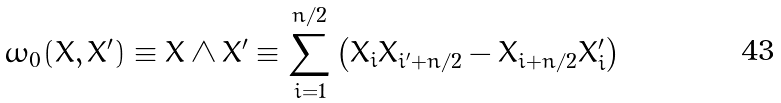<formula> <loc_0><loc_0><loc_500><loc_500>\omega _ { 0 } ( X , X ^ { \prime } ) \equiv X \wedge X ^ { \prime } \equiv \sum _ { i = 1 } ^ { n / 2 } \left ( X _ { i } X _ { i ^ { \prime } + n / 2 } - X _ { i + n / 2 } X _ { i } ^ { \prime } \right )</formula> 